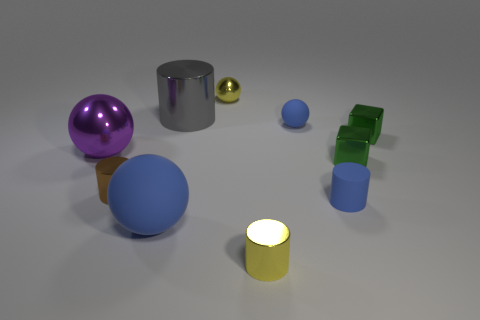What is the shape of the object that is both in front of the matte cylinder and to the right of the big gray object?
Provide a succinct answer. Cylinder. What is the size of the shiny sphere on the right side of the tiny brown metal object?
Your response must be concise. Small. There is a small cylinder that is to the right of the small yellow cylinder; is its color the same as the big matte sphere?
Give a very brief answer. Yes. What number of yellow shiny things have the same shape as the large gray object?
Give a very brief answer. 1. How many things are either blue rubber things that are in front of the brown thing or matte objects that are to the left of the small metallic ball?
Provide a short and direct response. 2. What number of red things are tiny matte things or large matte balls?
Provide a succinct answer. 0. What material is the blue object that is both right of the gray cylinder and in front of the large purple sphere?
Offer a terse response. Rubber. Is the purple object made of the same material as the small brown object?
Offer a very short reply. Yes. How many metal blocks are the same size as the gray thing?
Your answer should be very brief. 0. Is the number of tiny yellow metallic cylinders to the right of the small matte sphere the same as the number of large brown metal objects?
Your answer should be very brief. Yes. 